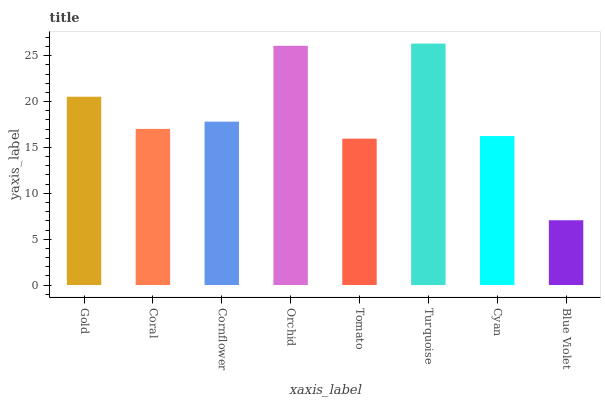Is Blue Violet the minimum?
Answer yes or no. Yes. Is Turquoise the maximum?
Answer yes or no. Yes. Is Coral the minimum?
Answer yes or no. No. Is Coral the maximum?
Answer yes or no. No. Is Gold greater than Coral?
Answer yes or no. Yes. Is Coral less than Gold?
Answer yes or no. Yes. Is Coral greater than Gold?
Answer yes or no. No. Is Gold less than Coral?
Answer yes or no. No. Is Cornflower the high median?
Answer yes or no. Yes. Is Coral the low median?
Answer yes or no. Yes. Is Blue Violet the high median?
Answer yes or no. No. Is Turquoise the low median?
Answer yes or no. No. 